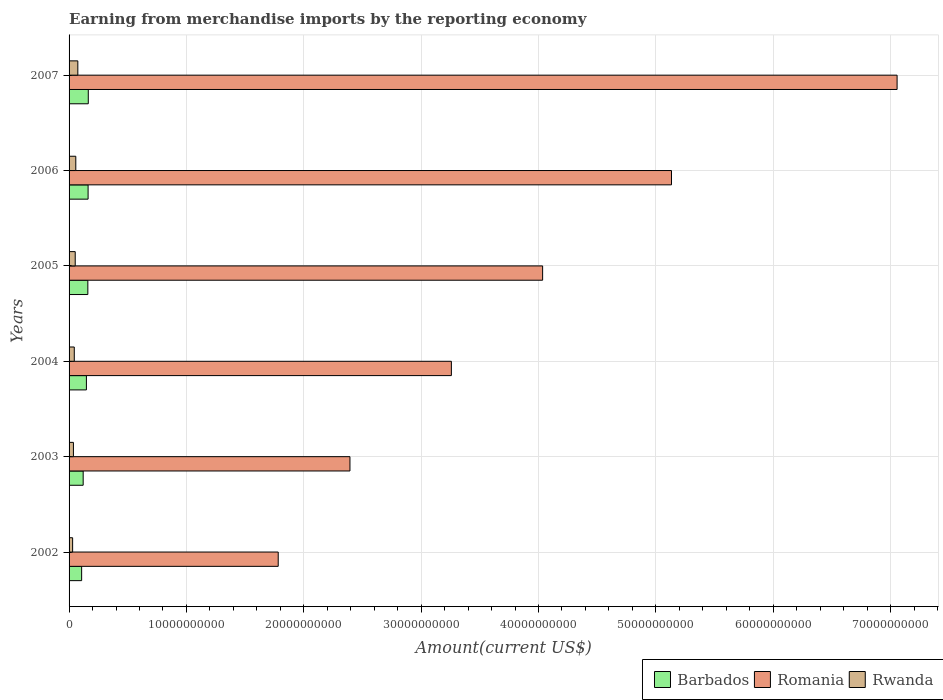How many different coloured bars are there?
Ensure brevity in your answer.  3. How many groups of bars are there?
Your response must be concise. 6. How many bars are there on the 1st tick from the bottom?
Your answer should be very brief. 3. In how many cases, is the number of bars for a given year not equal to the number of legend labels?
Offer a terse response. 0. What is the amount earned from merchandise imports in Barbados in 2007?
Offer a terse response. 1.64e+09. Across all years, what is the maximum amount earned from merchandise imports in Rwanda?
Ensure brevity in your answer.  7.46e+08. Across all years, what is the minimum amount earned from merchandise imports in Rwanda?
Offer a very short reply. 3.03e+08. In which year was the amount earned from merchandise imports in Barbados maximum?
Offer a terse response. 2007. What is the total amount earned from merchandise imports in Romania in the graph?
Give a very brief answer. 2.37e+11. What is the difference between the amount earned from merchandise imports in Barbados in 2003 and that in 2006?
Provide a short and direct response. -4.19e+08. What is the difference between the amount earned from merchandise imports in Rwanda in 2006 and the amount earned from merchandise imports in Barbados in 2005?
Keep it short and to the point. -1.03e+09. What is the average amount earned from merchandise imports in Romania per year?
Offer a terse response. 3.94e+1. In the year 2007, what is the difference between the amount earned from merchandise imports in Romania and amount earned from merchandise imports in Barbados?
Your response must be concise. 6.89e+1. In how many years, is the amount earned from merchandise imports in Barbados greater than 34000000000 US$?
Offer a very short reply. 0. What is the ratio of the amount earned from merchandise imports in Rwanda in 2002 to that in 2006?
Offer a very short reply. 0.53. Is the difference between the amount earned from merchandise imports in Romania in 2003 and 2007 greater than the difference between the amount earned from merchandise imports in Barbados in 2003 and 2007?
Provide a succinct answer. No. What is the difference between the highest and the second highest amount earned from merchandise imports in Barbados?
Offer a terse response. 1.63e+07. What is the difference between the highest and the lowest amount earned from merchandise imports in Rwanda?
Provide a short and direct response. 4.43e+08. In how many years, is the amount earned from merchandise imports in Rwanda greater than the average amount earned from merchandise imports in Rwanda taken over all years?
Offer a terse response. 3. What does the 3rd bar from the top in 2004 represents?
Provide a succinct answer. Barbados. What does the 3rd bar from the bottom in 2005 represents?
Your answer should be compact. Rwanda. How many bars are there?
Offer a very short reply. 18. Are the values on the major ticks of X-axis written in scientific E-notation?
Give a very brief answer. No. Does the graph contain any zero values?
Ensure brevity in your answer.  No. Does the graph contain grids?
Your answer should be very brief. Yes. How many legend labels are there?
Your answer should be very brief. 3. How are the legend labels stacked?
Offer a terse response. Horizontal. What is the title of the graph?
Make the answer very short. Earning from merchandise imports by the reporting economy. Does "Malawi" appear as one of the legend labels in the graph?
Provide a succinct answer. No. What is the label or title of the X-axis?
Give a very brief answer. Amount(current US$). What is the label or title of the Y-axis?
Provide a short and direct response. Years. What is the Amount(current US$) in Barbados in 2002?
Offer a terse response. 1.07e+09. What is the Amount(current US$) of Romania in 2002?
Keep it short and to the point. 1.78e+1. What is the Amount(current US$) in Rwanda in 2002?
Provide a short and direct response. 3.03e+08. What is the Amount(current US$) in Barbados in 2003?
Offer a very short reply. 1.20e+09. What is the Amount(current US$) of Romania in 2003?
Ensure brevity in your answer.  2.39e+1. What is the Amount(current US$) in Rwanda in 2003?
Provide a short and direct response. 3.70e+08. What is the Amount(current US$) in Barbados in 2004?
Ensure brevity in your answer.  1.48e+09. What is the Amount(current US$) of Romania in 2004?
Make the answer very short. 3.26e+1. What is the Amount(current US$) in Rwanda in 2004?
Your answer should be very brief. 4.43e+08. What is the Amount(current US$) of Barbados in 2005?
Provide a succinct answer. 1.60e+09. What is the Amount(current US$) of Romania in 2005?
Make the answer very short. 4.04e+1. What is the Amount(current US$) in Rwanda in 2005?
Provide a succinct answer. 5.23e+08. What is the Amount(current US$) in Barbados in 2006?
Keep it short and to the point. 1.62e+09. What is the Amount(current US$) of Romania in 2006?
Your answer should be very brief. 5.13e+1. What is the Amount(current US$) in Rwanda in 2006?
Your answer should be very brief. 5.74e+08. What is the Amount(current US$) of Barbados in 2007?
Offer a terse response. 1.64e+09. What is the Amount(current US$) of Romania in 2007?
Keep it short and to the point. 7.06e+1. What is the Amount(current US$) in Rwanda in 2007?
Make the answer very short. 7.46e+08. Across all years, what is the maximum Amount(current US$) in Barbados?
Offer a terse response. 1.64e+09. Across all years, what is the maximum Amount(current US$) in Romania?
Keep it short and to the point. 7.06e+1. Across all years, what is the maximum Amount(current US$) of Rwanda?
Your answer should be very brief. 7.46e+08. Across all years, what is the minimum Amount(current US$) in Barbados?
Your answer should be very brief. 1.07e+09. Across all years, what is the minimum Amount(current US$) of Romania?
Offer a terse response. 1.78e+1. Across all years, what is the minimum Amount(current US$) of Rwanda?
Offer a very short reply. 3.03e+08. What is the total Amount(current US$) of Barbados in the graph?
Your response must be concise. 8.61e+09. What is the total Amount(current US$) in Romania in the graph?
Your response must be concise. 2.37e+11. What is the total Amount(current US$) of Rwanda in the graph?
Keep it short and to the point. 2.96e+09. What is the difference between the Amount(current US$) in Barbados in 2002 and that in 2003?
Make the answer very short. -1.31e+08. What is the difference between the Amount(current US$) of Romania in 2002 and that in 2003?
Give a very brief answer. -6.11e+09. What is the difference between the Amount(current US$) in Rwanda in 2002 and that in 2003?
Offer a very short reply. -6.72e+07. What is the difference between the Amount(current US$) in Barbados in 2002 and that in 2004?
Provide a short and direct response. -4.06e+08. What is the difference between the Amount(current US$) of Romania in 2002 and that in 2004?
Offer a terse response. -1.48e+1. What is the difference between the Amount(current US$) of Rwanda in 2002 and that in 2004?
Make the answer very short. -1.40e+08. What is the difference between the Amount(current US$) in Barbados in 2002 and that in 2005?
Your answer should be very brief. -5.29e+08. What is the difference between the Amount(current US$) of Romania in 2002 and that in 2005?
Provide a succinct answer. -2.25e+1. What is the difference between the Amount(current US$) of Rwanda in 2002 and that in 2005?
Your response must be concise. -2.20e+08. What is the difference between the Amount(current US$) in Barbados in 2002 and that in 2006?
Make the answer very short. -5.50e+08. What is the difference between the Amount(current US$) of Romania in 2002 and that in 2006?
Your answer should be very brief. -3.35e+1. What is the difference between the Amount(current US$) of Rwanda in 2002 and that in 2006?
Your answer should be very brief. -2.71e+08. What is the difference between the Amount(current US$) of Barbados in 2002 and that in 2007?
Give a very brief answer. -5.66e+08. What is the difference between the Amount(current US$) of Romania in 2002 and that in 2007?
Keep it short and to the point. -5.27e+1. What is the difference between the Amount(current US$) in Rwanda in 2002 and that in 2007?
Offer a very short reply. -4.43e+08. What is the difference between the Amount(current US$) of Barbados in 2003 and that in 2004?
Provide a short and direct response. -2.74e+08. What is the difference between the Amount(current US$) in Romania in 2003 and that in 2004?
Your answer should be very brief. -8.64e+09. What is the difference between the Amount(current US$) of Rwanda in 2003 and that in 2004?
Give a very brief answer. -7.31e+07. What is the difference between the Amount(current US$) of Barbados in 2003 and that in 2005?
Make the answer very short. -3.98e+08. What is the difference between the Amount(current US$) of Romania in 2003 and that in 2005?
Your answer should be compact. -1.64e+1. What is the difference between the Amount(current US$) of Rwanda in 2003 and that in 2005?
Provide a short and direct response. -1.53e+08. What is the difference between the Amount(current US$) in Barbados in 2003 and that in 2006?
Offer a very short reply. -4.19e+08. What is the difference between the Amount(current US$) in Romania in 2003 and that in 2006?
Ensure brevity in your answer.  -2.74e+1. What is the difference between the Amount(current US$) of Rwanda in 2003 and that in 2006?
Keep it short and to the point. -2.03e+08. What is the difference between the Amount(current US$) of Barbados in 2003 and that in 2007?
Your answer should be very brief. -4.35e+08. What is the difference between the Amount(current US$) in Romania in 2003 and that in 2007?
Give a very brief answer. -4.66e+1. What is the difference between the Amount(current US$) in Rwanda in 2003 and that in 2007?
Give a very brief answer. -3.76e+08. What is the difference between the Amount(current US$) of Barbados in 2004 and that in 2005?
Your answer should be very brief. -1.24e+08. What is the difference between the Amount(current US$) in Romania in 2004 and that in 2005?
Your answer should be very brief. -7.78e+09. What is the difference between the Amount(current US$) of Rwanda in 2004 and that in 2005?
Provide a succinct answer. -7.99e+07. What is the difference between the Amount(current US$) of Barbados in 2004 and that in 2006?
Provide a short and direct response. -1.44e+08. What is the difference between the Amount(current US$) of Romania in 2004 and that in 2006?
Give a very brief answer. -1.88e+1. What is the difference between the Amount(current US$) in Rwanda in 2004 and that in 2006?
Keep it short and to the point. -1.30e+08. What is the difference between the Amount(current US$) in Barbados in 2004 and that in 2007?
Your answer should be very brief. -1.61e+08. What is the difference between the Amount(current US$) in Romania in 2004 and that in 2007?
Ensure brevity in your answer.  -3.80e+1. What is the difference between the Amount(current US$) of Rwanda in 2004 and that in 2007?
Your answer should be compact. -3.03e+08. What is the difference between the Amount(current US$) of Barbados in 2005 and that in 2006?
Offer a very short reply. -2.07e+07. What is the difference between the Amount(current US$) of Romania in 2005 and that in 2006?
Keep it short and to the point. -1.10e+1. What is the difference between the Amount(current US$) in Rwanda in 2005 and that in 2006?
Your response must be concise. -5.04e+07. What is the difference between the Amount(current US$) of Barbados in 2005 and that in 2007?
Offer a terse response. -3.71e+07. What is the difference between the Amount(current US$) in Romania in 2005 and that in 2007?
Give a very brief answer. -3.02e+1. What is the difference between the Amount(current US$) of Rwanda in 2005 and that in 2007?
Your answer should be compact. -2.23e+08. What is the difference between the Amount(current US$) in Barbados in 2006 and that in 2007?
Ensure brevity in your answer.  -1.63e+07. What is the difference between the Amount(current US$) in Romania in 2006 and that in 2007?
Your response must be concise. -1.92e+1. What is the difference between the Amount(current US$) in Rwanda in 2006 and that in 2007?
Offer a very short reply. -1.72e+08. What is the difference between the Amount(current US$) of Barbados in 2002 and the Amount(current US$) of Romania in 2003?
Ensure brevity in your answer.  -2.29e+1. What is the difference between the Amount(current US$) in Barbados in 2002 and the Amount(current US$) in Rwanda in 2003?
Keep it short and to the point. 7.01e+08. What is the difference between the Amount(current US$) of Romania in 2002 and the Amount(current US$) of Rwanda in 2003?
Make the answer very short. 1.75e+1. What is the difference between the Amount(current US$) of Barbados in 2002 and the Amount(current US$) of Romania in 2004?
Offer a very short reply. -3.15e+1. What is the difference between the Amount(current US$) of Barbados in 2002 and the Amount(current US$) of Rwanda in 2004?
Keep it short and to the point. 6.27e+08. What is the difference between the Amount(current US$) in Romania in 2002 and the Amount(current US$) in Rwanda in 2004?
Your answer should be compact. 1.74e+1. What is the difference between the Amount(current US$) of Barbados in 2002 and the Amount(current US$) of Romania in 2005?
Keep it short and to the point. -3.93e+1. What is the difference between the Amount(current US$) of Barbados in 2002 and the Amount(current US$) of Rwanda in 2005?
Offer a terse response. 5.48e+08. What is the difference between the Amount(current US$) of Romania in 2002 and the Amount(current US$) of Rwanda in 2005?
Offer a very short reply. 1.73e+1. What is the difference between the Amount(current US$) in Barbados in 2002 and the Amount(current US$) in Romania in 2006?
Give a very brief answer. -5.03e+1. What is the difference between the Amount(current US$) of Barbados in 2002 and the Amount(current US$) of Rwanda in 2006?
Keep it short and to the point. 4.97e+08. What is the difference between the Amount(current US$) of Romania in 2002 and the Amount(current US$) of Rwanda in 2006?
Ensure brevity in your answer.  1.72e+1. What is the difference between the Amount(current US$) in Barbados in 2002 and the Amount(current US$) in Romania in 2007?
Offer a very short reply. -6.95e+1. What is the difference between the Amount(current US$) in Barbados in 2002 and the Amount(current US$) in Rwanda in 2007?
Provide a short and direct response. 3.25e+08. What is the difference between the Amount(current US$) of Romania in 2002 and the Amount(current US$) of Rwanda in 2007?
Your answer should be compact. 1.71e+1. What is the difference between the Amount(current US$) of Barbados in 2003 and the Amount(current US$) of Romania in 2004?
Keep it short and to the point. -3.14e+1. What is the difference between the Amount(current US$) of Barbados in 2003 and the Amount(current US$) of Rwanda in 2004?
Provide a short and direct response. 7.59e+08. What is the difference between the Amount(current US$) in Romania in 2003 and the Amount(current US$) in Rwanda in 2004?
Your response must be concise. 2.35e+1. What is the difference between the Amount(current US$) in Barbados in 2003 and the Amount(current US$) in Romania in 2005?
Provide a succinct answer. -3.91e+1. What is the difference between the Amount(current US$) in Barbados in 2003 and the Amount(current US$) in Rwanda in 2005?
Offer a terse response. 6.79e+08. What is the difference between the Amount(current US$) in Romania in 2003 and the Amount(current US$) in Rwanda in 2005?
Keep it short and to the point. 2.34e+1. What is the difference between the Amount(current US$) in Barbados in 2003 and the Amount(current US$) in Romania in 2006?
Ensure brevity in your answer.  -5.01e+1. What is the difference between the Amount(current US$) in Barbados in 2003 and the Amount(current US$) in Rwanda in 2006?
Provide a short and direct response. 6.28e+08. What is the difference between the Amount(current US$) in Romania in 2003 and the Amount(current US$) in Rwanda in 2006?
Your answer should be compact. 2.34e+1. What is the difference between the Amount(current US$) of Barbados in 2003 and the Amount(current US$) of Romania in 2007?
Your answer should be compact. -6.94e+1. What is the difference between the Amount(current US$) of Barbados in 2003 and the Amount(current US$) of Rwanda in 2007?
Keep it short and to the point. 4.56e+08. What is the difference between the Amount(current US$) of Romania in 2003 and the Amount(current US$) of Rwanda in 2007?
Offer a very short reply. 2.32e+1. What is the difference between the Amount(current US$) of Barbados in 2004 and the Amount(current US$) of Romania in 2005?
Offer a terse response. -3.89e+1. What is the difference between the Amount(current US$) of Barbados in 2004 and the Amount(current US$) of Rwanda in 2005?
Your answer should be very brief. 9.53e+08. What is the difference between the Amount(current US$) of Romania in 2004 and the Amount(current US$) of Rwanda in 2005?
Your answer should be compact. 3.21e+1. What is the difference between the Amount(current US$) in Barbados in 2004 and the Amount(current US$) in Romania in 2006?
Ensure brevity in your answer.  -4.99e+1. What is the difference between the Amount(current US$) in Barbados in 2004 and the Amount(current US$) in Rwanda in 2006?
Your response must be concise. 9.03e+08. What is the difference between the Amount(current US$) in Romania in 2004 and the Amount(current US$) in Rwanda in 2006?
Make the answer very short. 3.20e+1. What is the difference between the Amount(current US$) in Barbados in 2004 and the Amount(current US$) in Romania in 2007?
Your answer should be very brief. -6.91e+1. What is the difference between the Amount(current US$) in Barbados in 2004 and the Amount(current US$) in Rwanda in 2007?
Give a very brief answer. 7.31e+08. What is the difference between the Amount(current US$) of Romania in 2004 and the Amount(current US$) of Rwanda in 2007?
Ensure brevity in your answer.  3.18e+1. What is the difference between the Amount(current US$) in Barbados in 2005 and the Amount(current US$) in Romania in 2006?
Your answer should be compact. -4.97e+1. What is the difference between the Amount(current US$) in Barbados in 2005 and the Amount(current US$) in Rwanda in 2006?
Your answer should be compact. 1.03e+09. What is the difference between the Amount(current US$) in Romania in 2005 and the Amount(current US$) in Rwanda in 2006?
Provide a short and direct response. 3.98e+1. What is the difference between the Amount(current US$) in Barbados in 2005 and the Amount(current US$) in Romania in 2007?
Make the answer very short. -6.90e+1. What is the difference between the Amount(current US$) in Barbados in 2005 and the Amount(current US$) in Rwanda in 2007?
Offer a very short reply. 8.54e+08. What is the difference between the Amount(current US$) in Romania in 2005 and the Amount(current US$) in Rwanda in 2007?
Give a very brief answer. 3.96e+1. What is the difference between the Amount(current US$) in Barbados in 2006 and the Amount(current US$) in Romania in 2007?
Provide a succinct answer. -6.89e+1. What is the difference between the Amount(current US$) in Barbados in 2006 and the Amount(current US$) in Rwanda in 2007?
Your answer should be very brief. 8.75e+08. What is the difference between the Amount(current US$) of Romania in 2006 and the Amount(current US$) of Rwanda in 2007?
Your answer should be very brief. 5.06e+1. What is the average Amount(current US$) of Barbados per year?
Keep it short and to the point. 1.43e+09. What is the average Amount(current US$) of Romania per year?
Your response must be concise. 3.94e+1. What is the average Amount(current US$) of Rwanda per year?
Give a very brief answer. 4.93e+08. In the year 2002, what is the difference between the Amount(current US$) in Barbados and Amount(current US$) in Romania?
Provide a short and direct response. -1.67e+1. In the year 2002, what is the difference between the Amount(current US$) in Barbados and Amount(current US$) in Rwanda?
Provide a short and direct response. 7.68e+08. In the year 2002, what is the difference between the Amount(current US$) of Romania and Amount(current US$) of Rwanda?
Make the answer very short. 1.75e+1. In the year 2003, what is the difference between the Amount(current US$) of Barbados and Amount(current US$) of Romania?
Your answer should be very brief. -2.27e+1. In the year 2003, what is the difference between the Amount(current US$) in Barbados and Amount(current US$) in Rwanda?
Your answer should be very brief. 8.32e+08. In the year 2003, what is the difference between the Amount(current US$) of Romania and Amount(current US$) of Rwanda?
Your response must be concise. 2.36e+1. In the year 2004, what is the difference between the Amount(current US$) of Barbados and Amount(current US$) of Romania?
Give a very brief answer. -3.11e+1. In the year 2004, what is the difference between the Amount(current US$) of Barbados and Amount(current US$) of Rwanda?
Your answer should be compact. 1.03e+09. In the year 2004, what is the difference between the Amount(current US$) in Romania and Amount(current US$) in Rwanda?
Offer a terse response. 3.21e+1. In the year 2005, what is the difference between the Amount(current US$) in Barbados and Amount(current US$) in Romania?
Provide a short and direct response. -3.87e+1. In the year 2005, what is the difference between the Amount(current US$) in Barbados and Amount(current US$) in Rwanda?
Offer a very short reply. 1.08e+09. In the year 2005, what is the difference between the Amount(current US$) in Romania and Amount(current US$) in Rwanda?
Offer a terse response. 3.98e+1. In the year 2006, what is the difference between the Amount(current US$) of Barbados and Amount(current US$) of Romania?
Offer a terse response. -4.97e+1. In the year 2006, what is the difference between the Amount(current US$) in Barbados and Amount(current US$) in Rwanda?
Keep it short and to the point. 1.05e+09. In the year 2006, what is the difference between the Amount(current US$) in Romania and Amount(current US$) in Rwanda?
Your answer should be very brief. 5.08e+1. In the year 2007, what is the difference between the Amount(current US$) in Barbados and Amount(current US$) in Romania?
Offer a terse response. -6.89e+1. In the year 2007, what is the difference between the Amount(current US$) in Barbados and Amount(current US$) in Rwanda?
Offer a terse response. 8.91e+08. In the year 2007, what is the difference between the Amount(current US$) in Romania and Amount(current US$) in Rwanda?
Ensure brevity in your answer.  6.98e+1. What is the ratio of the Amount(current US$) in Barbados in 2002 to that in 2003?
Your answer should be very brief. 0.89. What is the ratio of the Amount(current US$) of Romania in 2002 to that in 2003?
Your response must be concise. 0.74. What is the ratio of the Amount(current US$) of Rwanda in 2002 to that in 2003?
Offer a terse response. 0.82. What is the ratio of the Amount(current US$) of Barbados in 2002 to that in 2004?
Provide a succinct answer. 0.73. What is the ratio of the Amount(current US$) in Romania in 2002 to that in 2004?
Provide a succinct answer. 0.55. What is the ratio of the Amount(current US$) of Rwanda in 2002 to that in 2004?
Give a very brief answer. 0.68. What is the ratio of the Amount(current US$) of Barbados in 2002 to that in 2005?
Offer a terse response. 0.67. What is the ratio of the Amount(current US$) in Romania in 2002 to that in 2005?
Give a very brief answer. 0.44. What is the ratio of the Amount(current US$) in Rwanda in 2002 to that in 2005?
Your answer should be very brief. 0.58. What is the ratio of the Amount(current US$) of Barbados in 2002 to that in 2006?
Make the answer very short. 0.66. What is the ratio of the Amount(current US$) of Romania in 2002 to that in 2006?
Your answer should be very brief. 0.35. What is the ratio of the Amount(current US$) of Rwanda in 2002 to that in 2006?
Your answer should be very brief. 0.53. What is the ratio of the Amount(current US$) in Barbados in 2002 to that in 2007?
Give a very brief answer. 0.65. What is the ratio of the Amount(current US$) of Romania in 2002 to that in 2007?
Provide a succinct answer. 0.25. What is the ratio of the Amount(current US$) of Rwanda in 2002 to that in 2007?
Provide a short and direct response. 0.41. What is the ratio of the Amount(current US$) in Barbados in 2003 to that in 2004?
Provide a succinct answer. 0.81. What is the ratio of the Amount(current US$) in Romania in 2003 to that in 2004?
Your answer should be compact. 0.73. What is the ratio of the Amount(current US$) of Rwanda in 2003 to that in 2004?
Give a very brief answer. 0.84. What is the ratio of the Amount(current US$) in Barbados in 2003 to that in 2005?
Provide a succinct answer. 0.75. What is the ratio of the Amount(current US$) in Romania in 2003 to that in 2005?
Offer a terse response. 0.59. What is the ratio of the Amount(current US$) of Rwanda in 2003 to that in 2005?
Offer a terse response. 0.71. What is the ratio of the Amount(current US$) in Barbados in 2003 to that in 2006?
Your response must be concise. 0.74. What is the ratio of the Amount(current US$) in Romania in 2003 to that in 2006?
Make the answer very short. 0.47. What is the ratio of the Amount(current US$) in Rwanda in 2003 to that in 2006?
Your answer should be very brief. 0.65. What is the ratio of the Amount(current US$) of Barbados in 2003 to that in 2007?
Give a very brief answer. 0.73. What is the ratio of the Amount(current US$) in Romania in 2003 to that in 2007?
Offer a terse response. 0.34. What is the ratio of the Amount(current US$) of Rwanda in 2003 to that in 2007?
Offer a terse response. 0.5. What is the ratio of the Amount(current US$) of Barbados in 2004 to that in 2005?
Offer a terse response. 0.92. What is the ratio of the Amount(current US$) of Romania in 2004 to that in 2005?
Make the answer very short. 0.81. What is the ratio of the Amount(current US$) in Rwanda in 2004 to that in 2005?
Make the answer very short. 0.85. What is the ratio of the Amount(current US$) of Barbados in 2004 to that in 2006?
Offer a terse response. 0.91. What is the ratio of the Amount(current US$) in Romania in 2004 to that in 2006?
Your answer should be very brief. 0.63. What is the ratio of the Amount(current US$) in Rwanda in 2004 to that in 2006?
Offer a terse response. 0.77. What is the ratio of the Amount(current US$) in Barbados in 2004 to that in 2007?
Provide a short and direct response. 0.9. What is the ratio of the Amount(current US$) of Romania in 2004 to that in 2007?
Keep it short and to the point. 0.46. What is the ratio of the Amount(current US$) in Rwanda in 2004 to that in 2007?
Keep it short and to the point. 0.59. What is the ratio of the Amount(current US$) in Barbados in 2005 to that in 2006?
Keep it short and to the point. 0.99. What is the ratio of the Amount(current US$) in Romania in 2005 to that in 2006?
Keep it short and to the point. 0.79. What is the ratio of the Amount(current US$) of Rwanda in 2005 to that in 2006?
Your answer should be compact. 0.91. What is the ratio of the Amount(current US$) in Barbados in 2005 to that in 2007?
Give a very brief answer. 0.98. What is the ratio of the Amount(current US$) of Romania in 2005 to that in 2007?
Make the answer very short. 0.57. What is the ratio of the Amount(current US$) in Rwanda in 2005 to that in 2007?
Keep it short and to the point. 0.7. What is the ratio of the Amount(current US$) in Romania in 2006 to that in 2007?
Your answer should be compact. 0.73. What is the ratio of the Amount(current US$) of Rwanda in 2006 to that in 2007?
Your answer should be very brief. 0.77. What is the difference between the highest and the second highest Amount(current US$) in Barbados?
Your response must be concise. 1.63e+07. What is the difference between the highest and the second highest Amount(current US$) of Romania?
Make the answer very short. 1.92e+1. What is the difference between the highest and the second highest Amount(current US$) in Rwanda?
Ensure brevity in your answer.  1.72e+08. What is the difference between the highest and the lowest Amount(current US$) of Barbados?
Your response must be concise. 5.66e+08. What is the difference between the highest and the lowest Amount(current US$) of Romania?
Offer a terse response. 5.27e+1. What is the difference between the highest and the lowest Amount(current US$) of Rwanda?
Provide a short and direct response. 4.43e+08. 